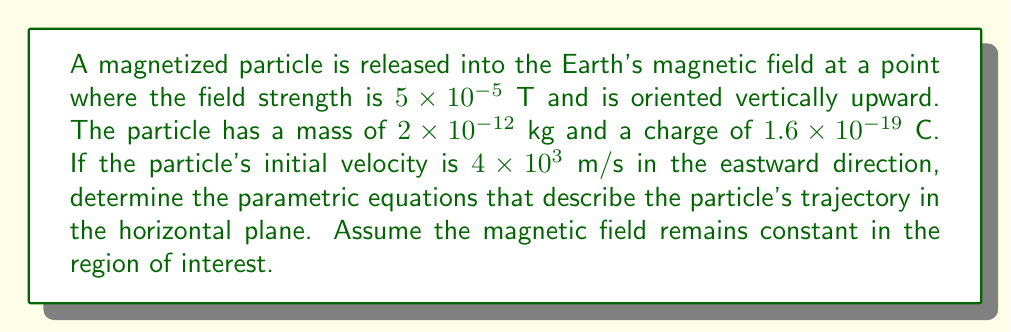What is the answer to this math problem? To solve this problem, we need to follow these steps:

1) First, recall that the force on a charged particle in a magnetic field is given by the Lorentz force equation:

   $$\mathbf{F} = q(\mathbf{v} \times \mathbf{B})$$

   where $q$ is the charge, $\mathbf{v}$ is the velocity, and $\mathbf{B}$ is the magnetic field.

2) In this case, $\mathbf{v}$ is initially in the x-direction (east) and $\mathbf{B}$ is in the z-direction (up). The resulting force will be in the y-direction (north), perpendicular to both $\mathbf{v}$ and $\mathbf{B}$.

3) The magnitude of this force is:

   $$F = qvB = (1.6 \times 10^{-19})(4 \times 10^3)(5 \times 10^{-5}) = 3.2 \times 10^{-20}\ \text{N}$$

4) This force causes the particle to move in a circular path in the xy-plane. The radius of this circle is given by:

   $$r = \frac{mv}{qB} = \frac{(2 \times 10^{-12})(4 \times 10^3)}{(1.6 \times 10^{-19})(5 \times 10^{-5})} = 1\ \text{m}$$

5) The angular frequency of this circular motion is:

   $$\omega = \frac{v}{r} = \frac{4 \times 10^3}{1} = 4 \times 10^3\ \text{rad/s}$$

6) Now, we can write the parametric equations for the particle's position as a function of time:

   $$x = r\sin(\omega t)$$
   $$y = r(1-\cos(\omega t))$$

   where we've chosen the initial position to be $(0,0)$ and the initial velocity to be in the x-direction.

7) Substituting our values for $r$ and $\omega$:

   $$x = \sin(4000t)$$
   $$y = 1-\cos(4000t)$$

These equations describe the trajectory of the particle in the horizontal plane.
Answer: The parametric equations describing the particle's trajectory in the horizontal plane are:

$$x = \sin(4000t)$$
$$y = 1-\cos(4000t)$$

where $x$ and $y$ are in meters and $t$ is in seconds. 